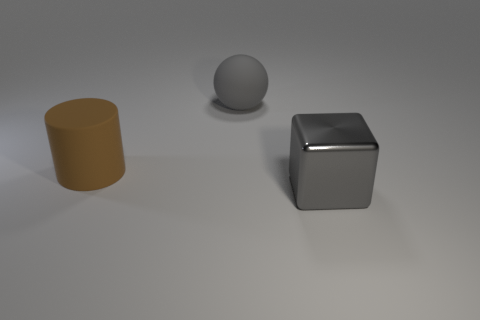There is a large thing behind the object left of the big gray rubber ball; is there a big matte sphere right of it?
Provide a succinct answer. No. The cylinder is what color?
Your response must be concise. Brown. Are there any matte cylinders left of the large gray matte ball?
Your answer should be very brief. Yes. What number of other objects are there of the same material as the big sphere?
Make the answer very short. 1. What is the color of the thing that is in front of the matte thing left of the gray thing behind the big gray metallic object?
Ensure brevity in your answer.  Gray. What is the shape of the object that is in front of the large thing that is on the left side of the rubber ball?
Ensure brevity in your answer.  Cube. Is the number of large gray things to the right of the brown thing greater than the number of large gray matte objects?
Keep it short and to the point. Yes. How many objects are things that are behind the shiny object or large brown matte cylinders?
Make the answer very short. 2. Is the number of large gray shiny objects greater than the number of matte things?
Offer a very short reply. No. Are there any gray cubes of the same size as the brown rubber object?
Offer a terse response. Yes. 